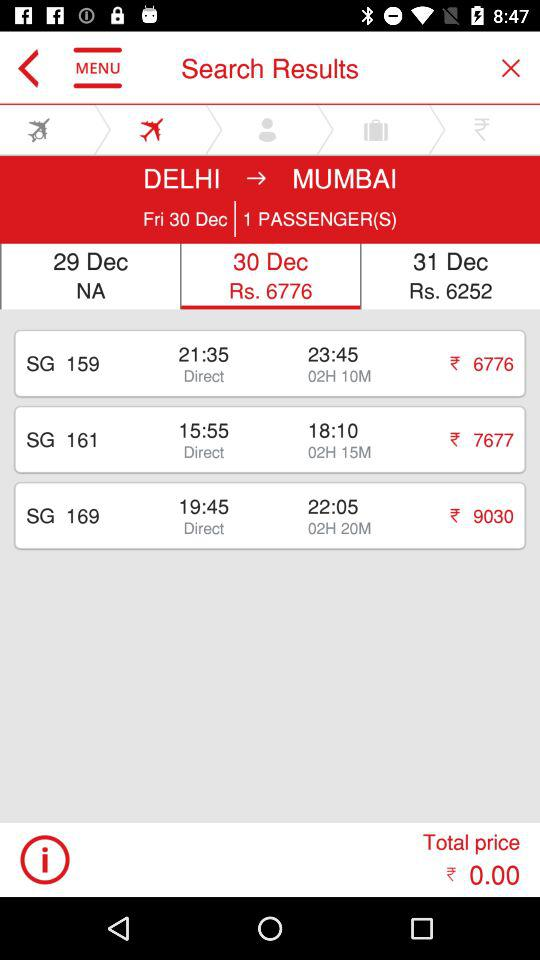What is the destination? The destination is Mumbai. 